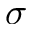Convert formula to latex. <formula><loc_0><loc_0><loc_500><loc_500>\sigma</formula> 